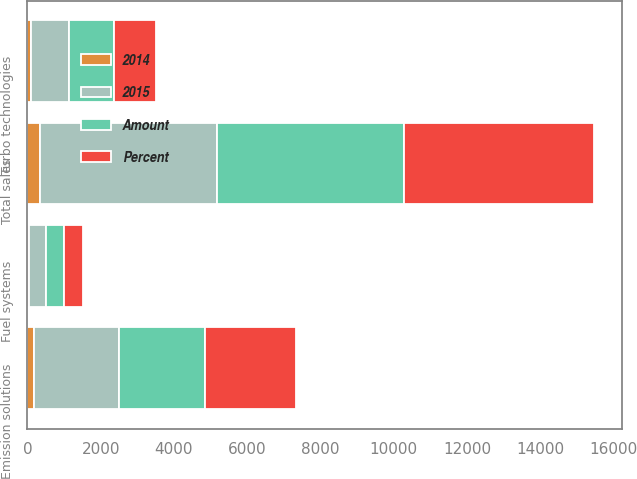<chart> <loc_0><loc_0><loc_500><loc_500><stacked_bar_chart><ecel><fcel>Emission solutions<fcel>Turbo technologies<fcel>Fuel systems<fcel>Total sales<nl><fcel>2015<fcel>2317<fcel>1036<fcel>473<fcel>4836<nl><fcel>Percent<fcel>2499<fcel>1141<fcel>522<fcel>5172<nl><fcel>Amount<fcel>2343<fcel>1222<fcel>478<fcel>5118<nl><fcel>2014<fcel>182<fcel>105<fcel>49<fcel>336<nl></chart> 